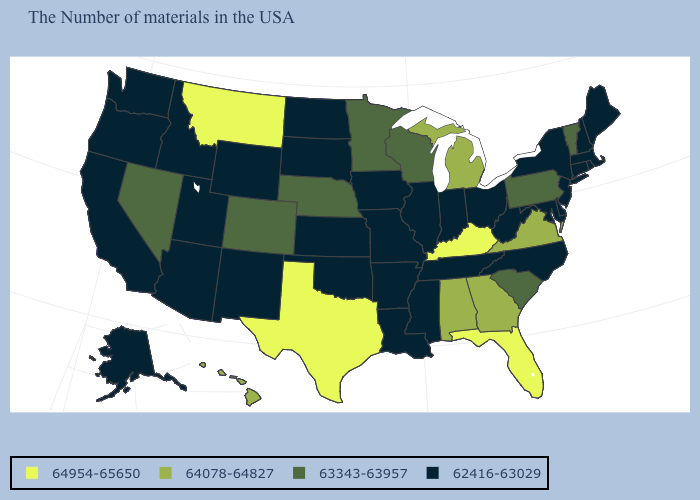Name the states that have a value in the range 62416-63029?
Write a very short answer. Maine, Massachusetts, Rhode Island, New Hampshire, Connecticut, New York, New Jersey, Delaware, Maryland, North Carolina, West Virginia, Ohio, Indiana, Tennessee, Illinois, Mississippi, Louisiana, Missouri, Arkansas, Iowa, Kansas, Oklahoma, South Dakota, North Dakota, Wyoming, New Mexico, Utah, Arizona, Idaho, California, Washington, Oregon, Alaska. How many symbols are there in the legend?
Write a very short answer. 4. Does the map have missing data?
Give a very brief answer. No. What is the lowest value in the West?
Be succinct. 62416-63029. Does Kentucky have the highest value in the USA?
Short answer required. Yes. Does Oregon have the same value as Oklahoma?
Give a very brief answer. Yes. Which states have the lowest value in the South?
Quick response, please. Delaware, Maryland, North Carolina, West Virginia, Tennessee, Mississippi, Louisiana, Arkansas, Oklahoma. What is the value of Montana?
Quick response, please. 64954-65650. Does Alabama have the lowest value in the South?
Answer briefly. No. What is the value of Tennessee?
Quick response, please. 62416-63029. What is the highest value in the South ?
Be succinct. 64954-65650. What is the value of Utah?
Short answer required. 62416-63029. Which states have the highest value in the USA?
Be succinct. Florida, Kentucky, Texas, Montana. Does Michigan have the highest value in the MidWest?
Concise answer only. Yes. 